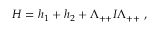Convert formula to latex. <formula><loc_0><loc_0><loc_500><loc_500>\begin{array} { r } { H = h _ { 1 } + h _ { 2 } + \Lambda _ { + + } I \Lambda _ { + + } \, , } \end{array}</formula> 